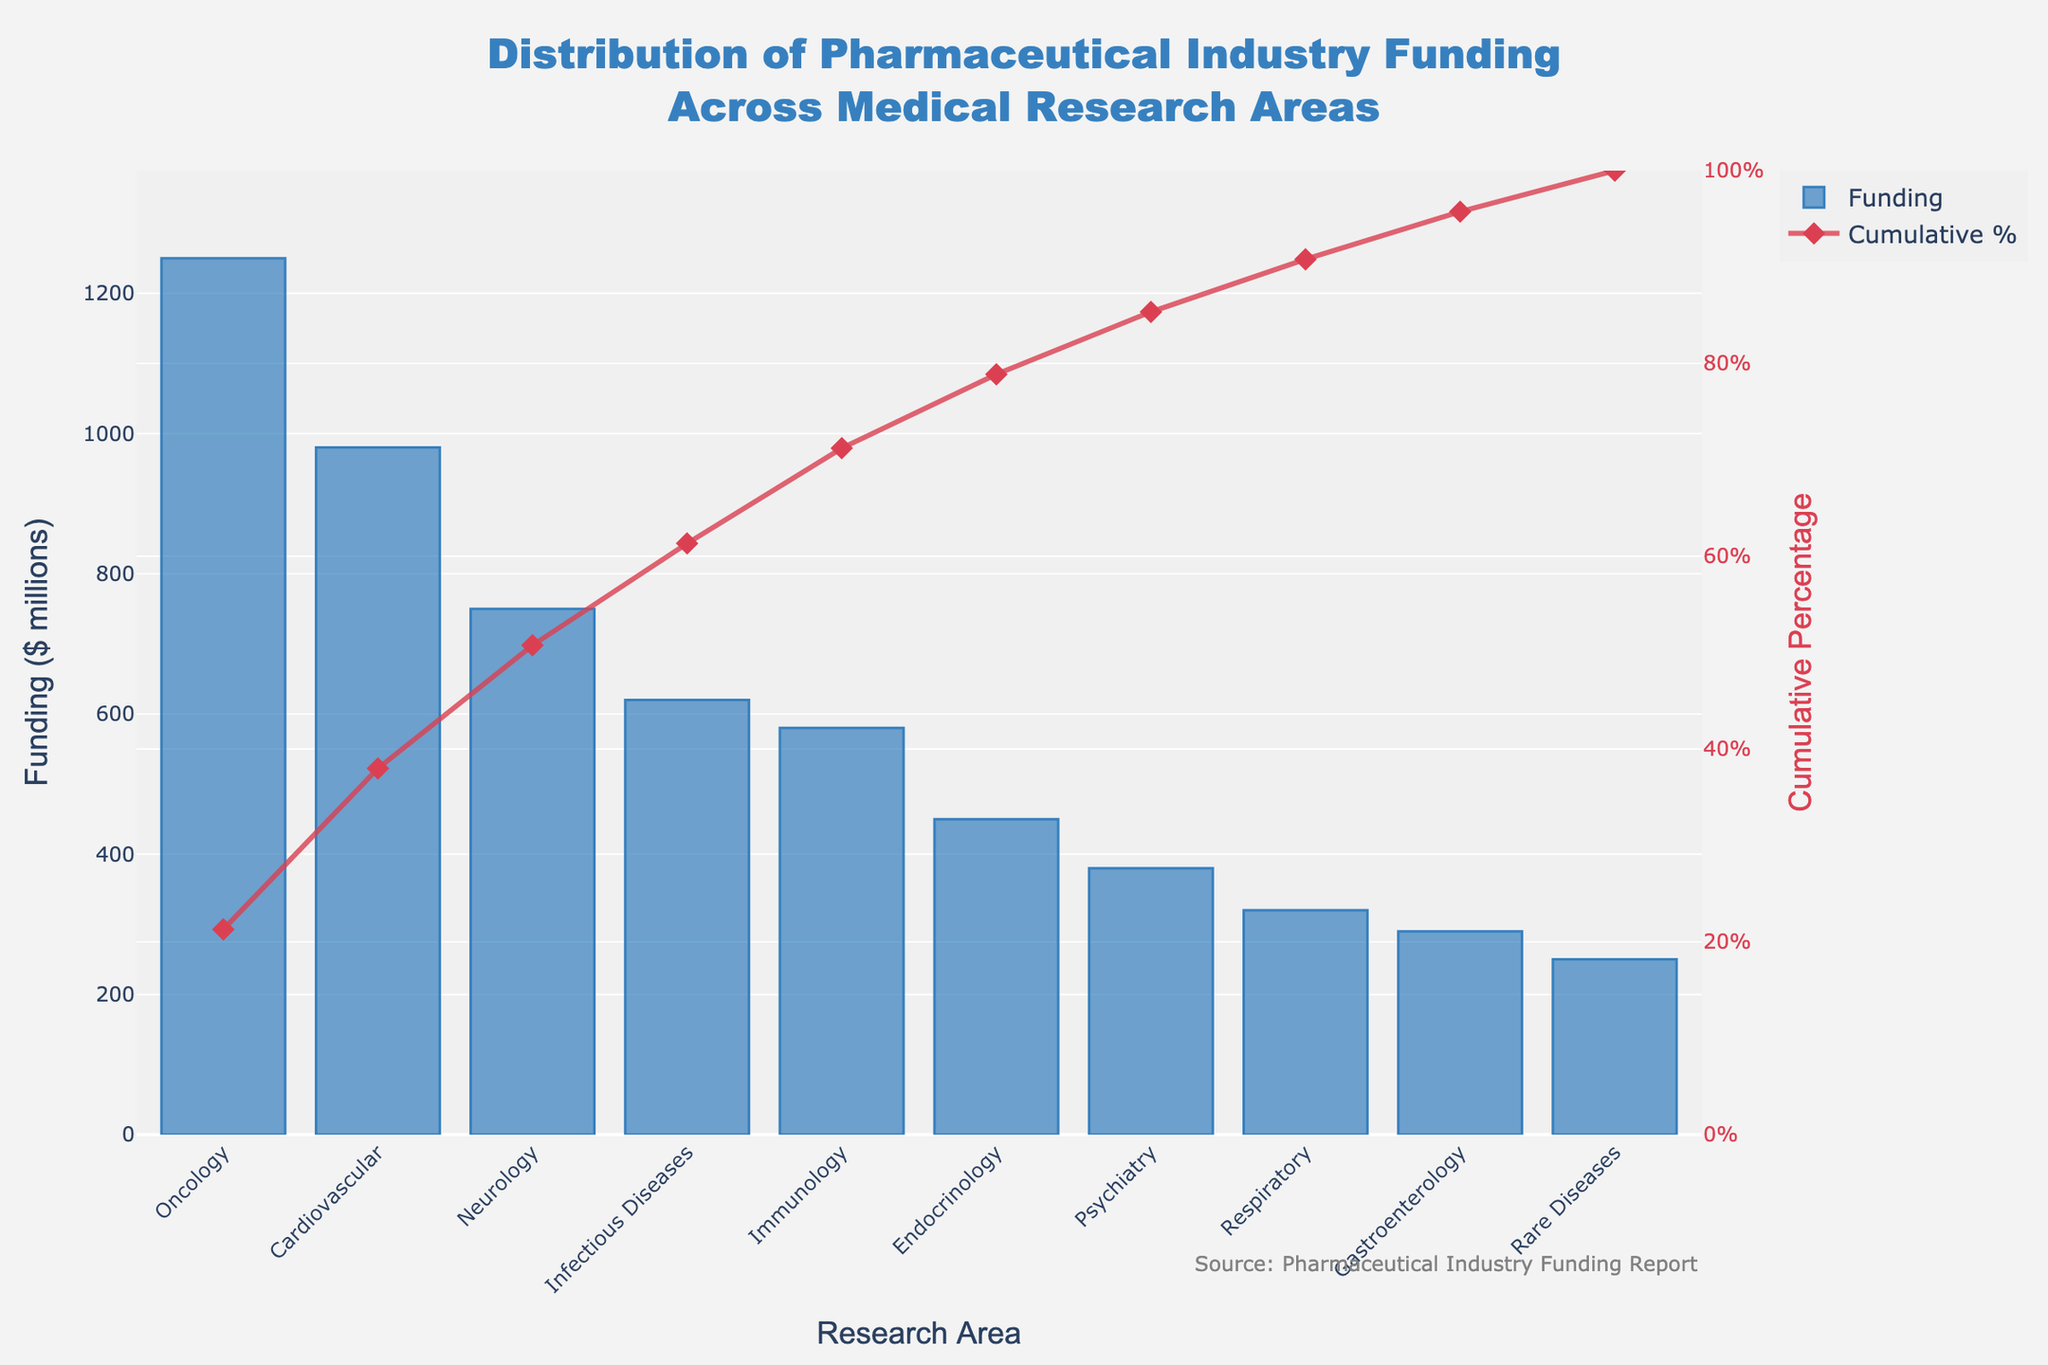How much funding is allocated to Oncology? The bar corresponding to Oncology shows its height indicating the amount of funding. Read the value from the y-axis where the bar ends.
Answer: $1250 million Which research area has the second highest funding? Observe the heights of the bars and identify the second tallest one.
Answer: Cardiovascular What is the cumulative percentage of funding by the time Neurology is reached? Trace the cumulative percentage line up to the Neurology label on the x-axis and see where it intersects on the right y-axis (Cumulative Percentage).
Answer: 66% How many research areas have more than $500 million funding? Count the number of bars whose heights exceed the $500 million mark on the y-axis.
Answer: Four What percentage of the total funding is covered by the top three research areas? Add the cumulative percentages up to the third research area (Oncology, Cardiovascular, Neurology) as shown on the cumulative percentage line.
Answer: 73.8% What is the difference in funding between Psychiatry and Endocrinology? Find the bar heights for both Psychiatry and Endocrinology and subtract the smaller from the larger.
Answer: $70 million Which research area has the least amount of funding? Identify the shortest bar on the chart indicating the lowest funding amount.
Answer: Rare Diseases How does the funding for Immunology compare to Respiratory research? Compare the heights of the bars for both Immunology and Respiratory research to decide which one is higher or if they are equal.
Answer: Immunology has more funding Is the cumulative percentage higher or lower than 50% when Infectious Diseases is included? See where the cumulative percentage line intersects with Infectious Diseases on the x-axis and check its value on the right y-axis.
Answer: Higher (54%) What's the total funding allocated by the time Gastroenterology is reached? Sum the funding amounts for Oncology, Cardiovascular, Neurology, Infectious Diseases, Immunology, Endocrinology, Psychiatry, and Gastroenterology.
Answer: $5,620 million 